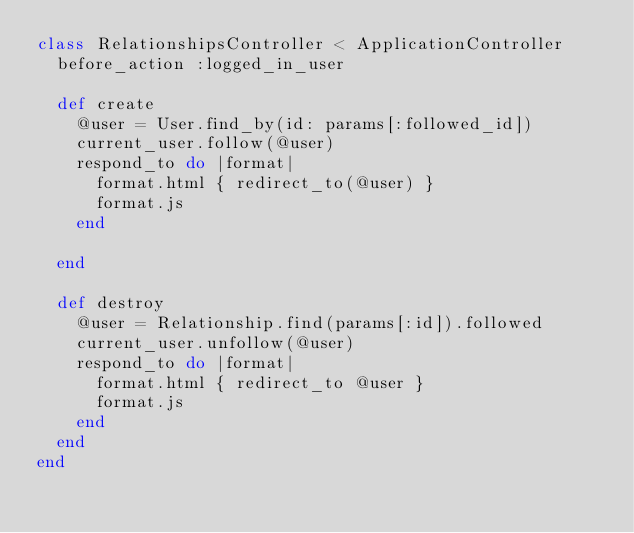<code> <loc_0><loc_0><loc_500><loc_500><_Ruby_>class RelationshipsController < ApplicationController
  before_action :logged_in_user

  def create
    @user = User.find_by(id: params[:followed_id])
    current_user.follow(@user)
    respond_to do |format|
      format.html { redirect_to(@user) }
      format.js
    end
    
  end

  def destroy
    @user = Relationship.find(params[:id]).followed
    current_user.unfollow(@user)
    respond_to do |format|
      format.html { redirect_to @user }
      format.js
    end
  end
end
</code> 